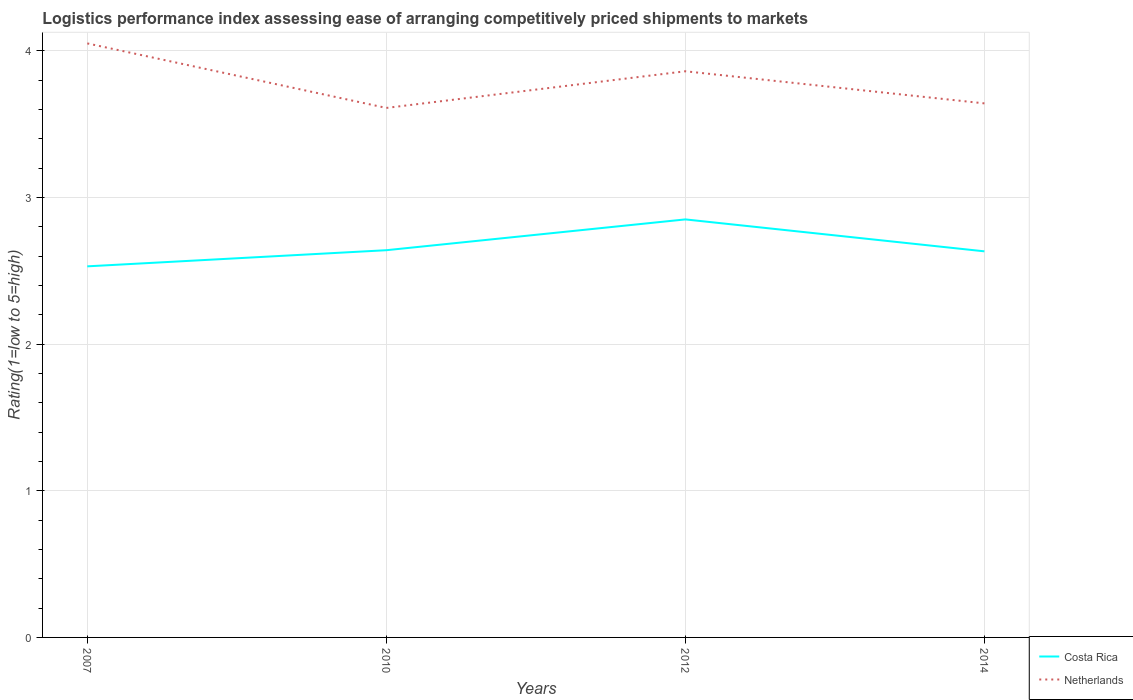Does the line corresponding to Costa Rica intersect with the line corresponding to Netherlands?
Your answer should be very brief. No. Is the number of lines equal to the number of legend labels?
Your answer should be very brief. Yes. Across all years, what is the maximum Logistic performance index in Costa Rica?
Give a very brief answer. 2.53. In which year was the Logistic performance index in Netherlands maximum?
Your response must be concise. 2010. What is the total Logistic performance index in Netherlands in the graph?
Keep it short and to the point. 0.22. What is the difference between the highest and the second highest Logistic performance index in Netherlands?
Your response must be concise. 0.44. What is the difference between the highest and the lowest Logistic performance index in Costa Rica?
Your response must be concise. 1. How many lines are there?
Make the answer very short. 2. How many years are there in the graph?
Give a very brief answer. 4. Where does the legend appear in the graph?
Make the answer very short. Bottom right. How many legend labels are there?
Keep it short and to the point. 2. How are the legend labels stacked?
Give a very brief answer. Vertical. What is the title of the graph?
Make the answer very short. Logistics performance index assessing ease of arranging competitively priced shipments to markets. What is the label or title of the X-axis?
Provide a short and direct response. Years. What is the label or title of the Y-axis?
Offer a terse response. Rating(1=low to 5=high). What is the Rating(1=low to 5=high) in Costa Rica in 2007?
Keep it short and to the point. 2.53. What is the Rating(1=low to 5=high) of Netherlands in 2007?
Provide a short and direct response. 4.05. What is the Rating(1=low to 5=high) of Costa Rica in 2010?
Give a very brief answer. 2.64. What is the Rating(1=low to 5=high) in Netherlands in 2010?
Provide a succinct answer. 3.61. What is the Rating(1=low to 5=high) in Costa Rica in 2012?
Your answer should be compact. 2.85. What is the Rating(1=low to 5=high) of Netherlands in 2012?
Provide a succinct answer. 3.86. What is the Rating(1=low to 5=high) in Costa Rica in 2014?
Provide a succinct answer. 2.63. What is the Rating(1=low to 5=high) of Netherlands in 2014?
Ensure brevity in your answer.  3.64. Across all years, what is the maximum Rating(1=low to 5=high) of Costa Rica?
Ensure brevity in your answer.  2.85. Across all years, what is the maximum Rating(1=low to 5=high) in Netherlands?
Offer a very short reply. 4.05. Across all years, what is the minimum Rating(1=low to 5=high) in Costa Rica?
Your response must be concise. 2.53. Across all years, what is the minimum Rating(1=low to 5=high) in Netherlands?
Give a very brief answer. 3.61. What is the total Rating(1=low to 5=high) in Costa Rica in the graph?
Your answer should be compact. 10.65. What is the total Rating(1=low to 5=high) of Netherlands in the graph?
Your answer should be very brief. 15.16. What is the difference between the Rating(1=low to 5=high) in Costa Rica in 2007 and that in 2010?
Offer a terse response. -0.11. What is the difference between the Rating(1=low to 5=high) in Netherlands in 2007 and that in 2010?
Make the answer very short. 0.44. What is the difference between the Rating(1=low to 5=high) in Costa Rica in 2007 and that in 2012?
Your answer should be very brief. -0.32. What is the difference between the Rating(1=low to 5=high) of Netherlands in 2007 and that in 2012?
Provide a succinct answer. 0.19. What is the difference between the Rating(1=low to 5=high) of Costa Rica in 2007 and that in 2014?
Your answer should be very brief. -0.1. What is the difference between the Rating(1=low to 5=high) in Netherlands in 2007 and that in 2014?
Give a very brief answer. 0.41. What is the difference between the Rating(1=low to 5=high) of Costa Rica in 2010 and that in 2012?
Provide a succinct answer. -0.21. What is the difference between the Rating(1=low to 5=high) in Costa Rica in 2010 and that in 2014?
Your answer should be very brief. 0.01. What is the difference between the Rating(1=low to 5=high) of Netherlands in 2010 and that in 2014?
Keep it short and to the point. -0.03. What is the difference between the Rating(1=low to 5=high) of Costa Rica in 2012 and that in 2014?
Your answer should be compact. 0.22. What is the difference between the Rating(1=low to 5=high) in Netherlands in 2012 and that in 2014?
Your answer should be compact. 0.22. What is the difference between the Rating(1=low to 5=high) in Costa Rica in 2007 and the Rating(1=low to 5=high) in Netherlands in 2010?
Make the answer very short. -1.08. What is the difference between the Rating(1=low to 5=high) of Costa Rica in 2007 and the Rating(1=low to 5=high) of Netherlands in 2012?
Your response must be concise. -1.33. What is the difference between the Rating(1=low to 5=high) of Costa Rica in 2007 and the Rating(1=low to 5=high) of Netherlands in 2014?
Your response must be concise. -1.11. What is the difference between the Rating(1=low to 5=high) in Costa Rica in 2010 and the Rating(1=low to 5=high) in Netherlands in 2012?
Provide a succinct answer. -1.22. What is the difference between the Rating(1=low to 5=high) of Costa Rica in 2010 and the Rating(1=low to 5=high) of Netherlands in 2014?
Your answer should be very brief. -1. What is the difference between the Rating(1=low to 5=high) in Costa Rica in 2012 and the Rating(1=low to 5=high) in Netherlands in 2014?
Your response must be concise. -0.79. What is the average Rating(1=low to 5=high) of Costa Rica per year?
Give a very brief answer. 2.66. What is the average Rating(1=low to 5=high) of Netherlands per year?
Your answer should be compact. 3.79. In the year 2007, what is the difference between the Rating(1=low to 5=high) of Costa Rica and Rating(1=low to 5=high) of Netherlands?
Ensure brevity in your answer.  -1.52. In the year 2010, what is the difference between the Rating(1=low to 5=high) in Costa Rica and Rating(1=low to 5=high) in Netherlands?
Offer a very short reply. -0.97. In the year 2012, what is the difference between the Rating(1=low to 5=high) in Costa Rica and Rating(1=low to 5=high) in Netherlands?
Offer a very short reply. -1.01. In the year 2014, what is the difference between the Rating(1=low to 5=high) in Costa Rica and Rating(1=low to 5=high) in Netherlands?
Provide a short and direct response. -1.01. What is the ratio of the Rating(1=low to 5=high) of Costa Rica in 2007 to that in 2010?
Keep it short and to the point. 0.96. What is the ratio of the Rating(1=low to 5=high) in Netherlands in 2007 to that in 2010?
Ensure brevity in your answer.  1.12. What is the ratio of the Rating(1=low to 5=high) of Costa Rica in 2007 to that in 2012?
Offer a terse response. 0.89. What is the ratio of the Rating(1=low to 5=high) in Netherlands in 2007 to that in 2012?
Provide a short and direct response. 1.05. What is the ratio of the Rating(1=low to 5=high) in Costa Rica in 2007 to that in 2014?
Provide a short and direct response. 0.96. What is the ratio of the Rating(1=low to 5=high) of Netherlands in 2007 to that in 2014?
Your response must be concise. 1.11. What is the ratio of the Rating(1=low to 5=high) in Costa Rica in 2010 to that in 2012?
Provide a succinct answer. 0.93. What is the ratio of the Rating(1=low to 5=high) in Netherlands in 2010 to that in 2012?
Make the answer very short. 0.94. What is the ratio of the Rating(1=low to 5=high) of Costa Rica in 2010 to that in 2014?
Your answer should be very brief. 1. What is the ratio of the Rating(1=low to 5=high) of Costa Rica in 2012 to that in 2014?
Keep it short and to the point. 1.08. What is the ratio of the Rating(1=low to 5=high) in Netherlands in 2012 to that in 2014?
Your answer should be compact. 1.06. What is the difference between the highest and the second highest Rating(1=low to 5=high) of Costa Rica?
Offer a very short reply. 0.21. What is the difference between the highest and the second highest Rating(1=low to 5=high) in Netherlands?
Provide a succinct answer. 0.19. What is the difference between the highest and the lowest Rating(1=low to 5=high) in Costa Rica?
Ensure brevity in your answer.  0.32. What is the difference between the highest and the lowest Rating(1=low to 5=high) in Netherlands?
Provide a short and direct response. 0.44. 